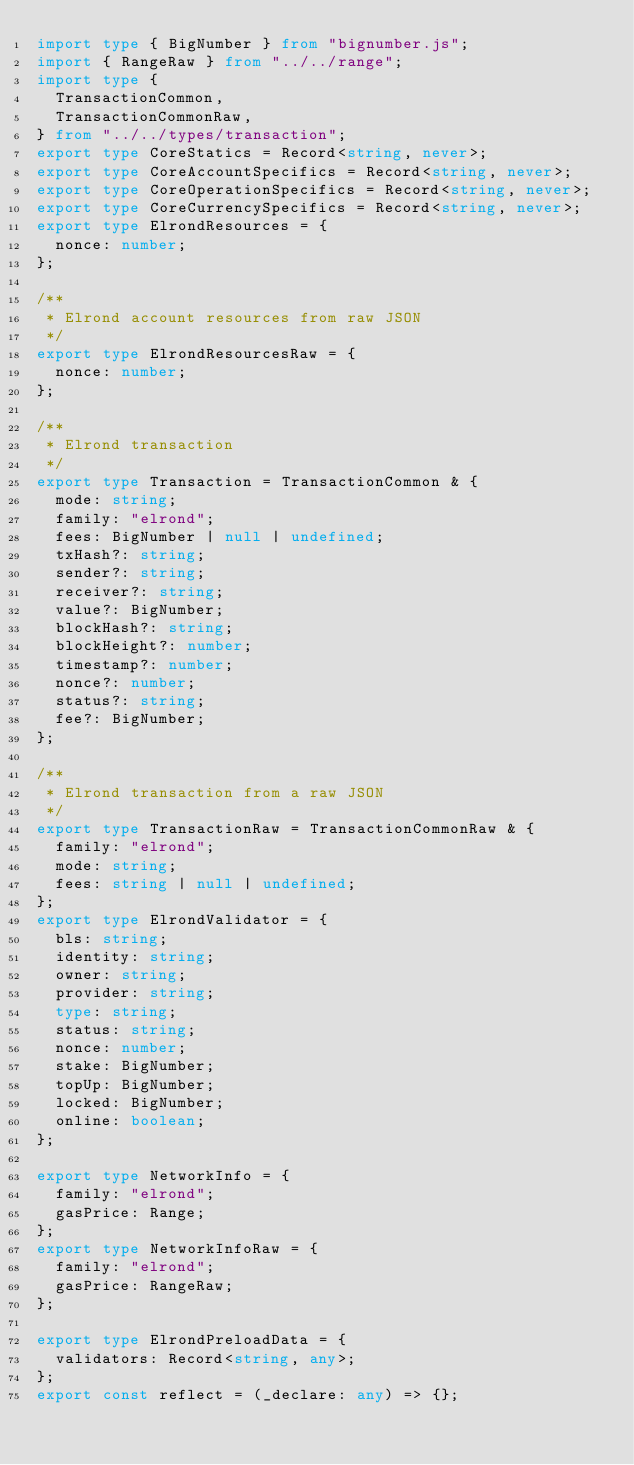<code> <loc_0><loc_0><loc_500><loc_500><_TypeScript_>import type { BigNumber } from "bignumber.js";
import { RangeRaw } from "../../range";
import type {
  TransactionCommon,
  TransactionCommonRaw,
} from "../../types/transaction";
export type CoreStatics = Record<string, never>;
export type CoreAccountSpecifics = Record<string, never>;
export type CoreOperationSpecifics = Record<string, never>;
export type CoreCurrencySpecifics = Record<string, never>;
export type ElrondResources = {
  nonce: number;
};

/**
 * Elrond account resources from raw JSON
 */
export type ElrondResourcesRaw = {
  nonce: number;
};

/**
 * Elrond transaction
 */
export type Transaction = TransactionCommon & {
  mode: string;
  family: "elrond";
  fees: BigNumber | null | undefined;
  txHash?: string;
  sender?: string;
  receiver?: string;
  value?: BigNumber;
  blockHash?: string;
  blockHeight?: number;
  timestamp?: number;
  nonce?: number;
  status?: string;
  fee?: BigNumber;
};

/**
 * Elrond transaction from a raw JSON
 */
export type TransactionRaw = TransactionCommonRaw & {
  family: "elrond";
  mode: string;
  fees: string | null | undefined;
};
export type ElrondValidator = {
  bls: string;
  identity: string;
  owner: string;
  provider: string;
  type: string;
  status: string;
  nonce: number;
  stake: BigNumber;
  topUp: BigNumber;
  locked: BigNumber;
  online: boolean;
};

export type NetworkInfo = {
  family: "elrond";
  gasPrice: Range;
};
export type NetworkInfoRaw = {
  family: "elrond";
  gasPrice: RangeRaw;
};

export type ElrondPreloadData = {
  validators: Record<string, any>;
};
export const reflect = (_declare: any) => {};
</code> 